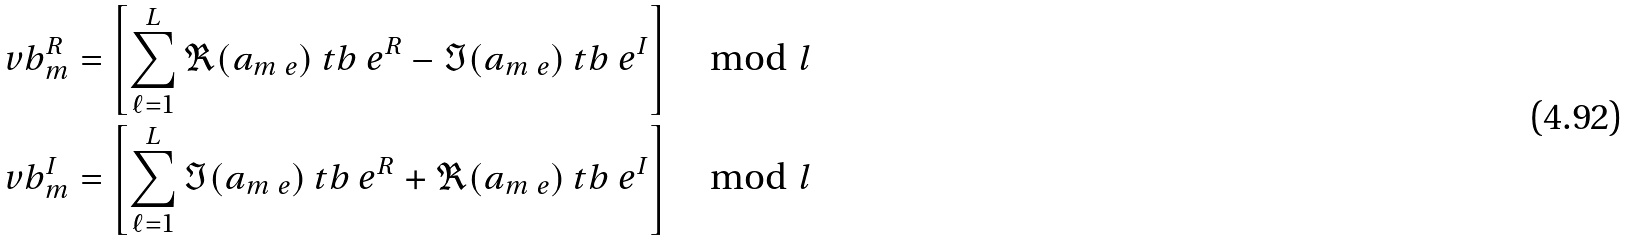<formula> <loc_0><loc_0><loc_500><loc_500>\ v b _ { m } ^ { R } = \left [ \sum _ { \ell = 1 } ^ { L } { \Re ( a _ { m \ e } ) \ t b _ { \ } e ^ { R } - \Im ( a _ { m \ e } ) \ t b _ { \ } e ^ { I } } \right ] \mod l \\ \ v b _ { m } ^ { I } = \left [ \sum _ { \ell = 1 } ^ { L } { \Im ( a _ { m \ e } ) \ t b _ { \ } e ^ { R } + \Re ( a _ { m \ e } ) \ t b _ { \ } e ^ { I } } \right ] \mod l</formula> 